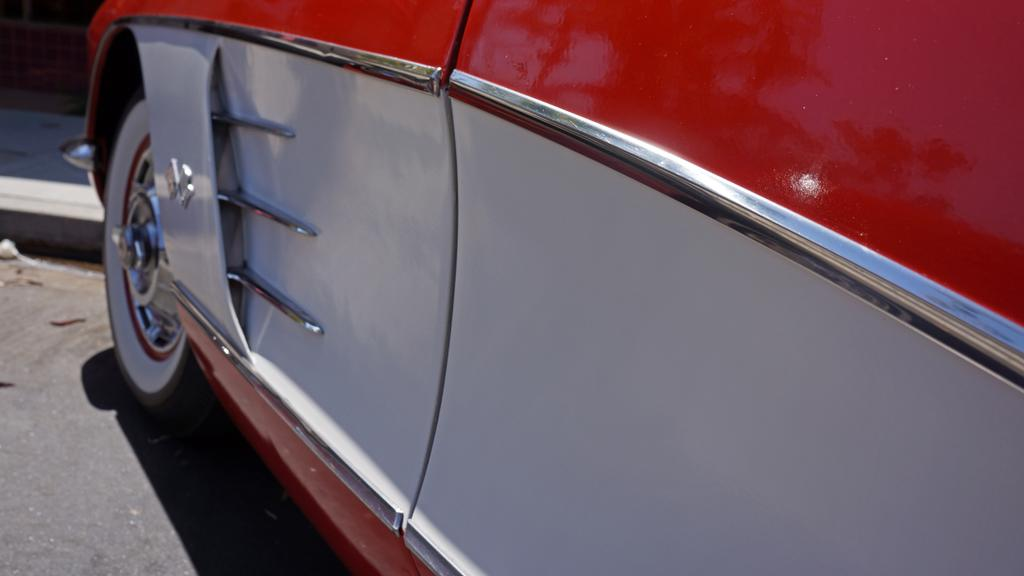What is the main subject of the image? The main subject of the image is a car. What are some features of the car? The car has a wheel and a door. What is the color of the door? The door is red and white in color. How does the car express its temper in the image? Cars do not have emotions or the ability to express temper, so this question cannot be answered. 